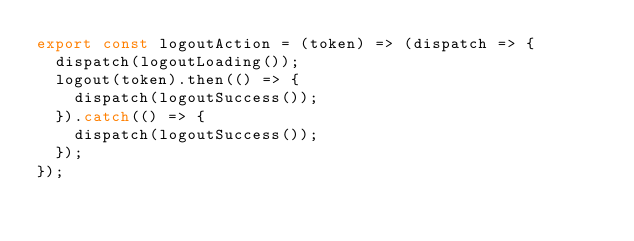<code> <loc_0><loc_0><loc_500><loc_500><_JavaScript_>export const logoutAction = (token) => (dispatch => {
  dispatch(logoutLoading());
  logout(token).then(() => {
    dispatch(logoutSuccess());
  }).catch(() => {
    dispatch(logoutSuccess());
  });
});

</code> 